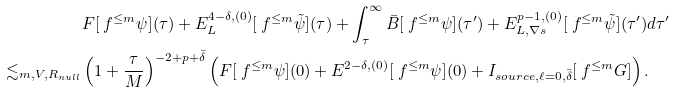Convert formula to latex. <formula><loc_0><loc_0><loc_500><loc_500>& F [ \ f ^ { \leq m } \psi ] ( \tau ) + E ^ { 4 - \delta , ( 0 ) } _ { L } [ \ f ^ { \leq m } \tilde { \psi } ] ( \tau ) + \int _ { \tau } ^ { \infty } \bar { B } [ \ f ^ { \leq m } \psi ] ( \tau ^ { \prime } ) + E ^ { p - 1 , ( 0 ) } _ { L , \nabla s } [ \ f ^ { \leq m } \tilde { \psi } ] ( \tau ^ { \prime } ) d \tau ^ { \prime } \\ \lesssim _ { m , V , R _ { n u l l } } & \left ( 1 + \frac { \tau } { M } \right ) ^ { - 2 + p + \bar { \delta } } \left ( F [ \ f ^ { \leq m } \psi ] ( 0 ) + E ^ { 2 - \delta , ( 0 ) } [ \ f ^ { \leq m } \psi ] ( 0 ) + I _ { s o u r c e , \ell = 0 , \bar { \delta } } [ \ f ^ { \leq m } G ] \right ) .</formula> 